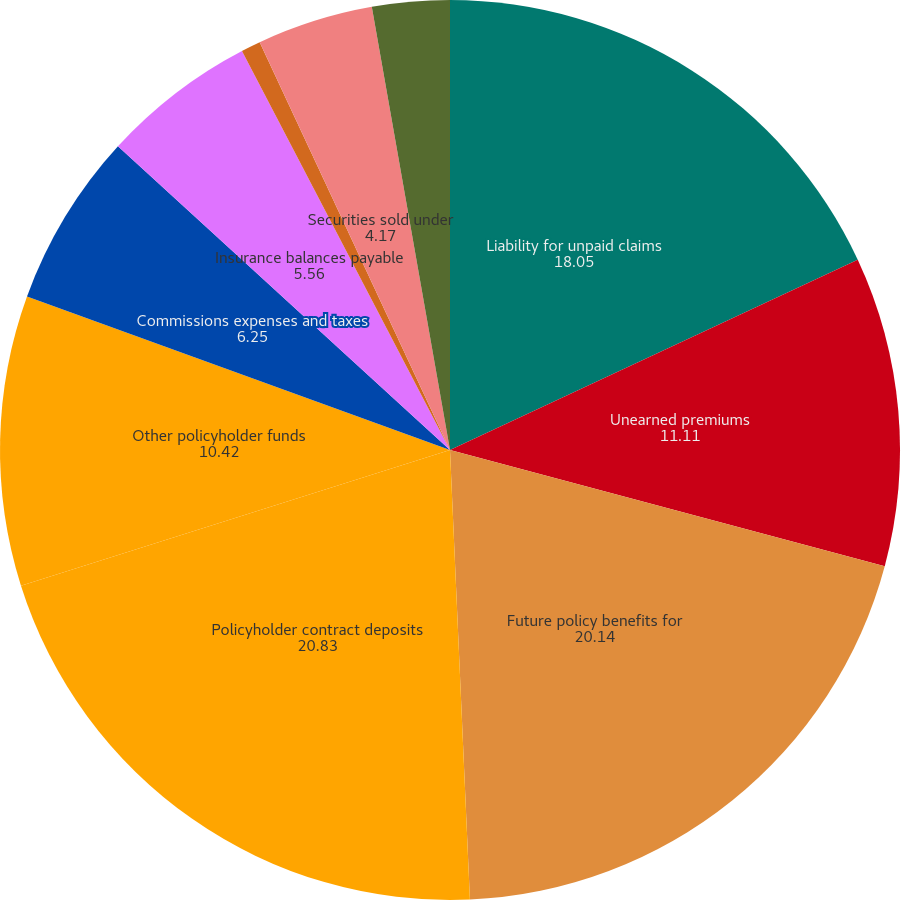<chart> <loc_0><loc_0><loc_500><loc_500><pie_chart><fcel>Liability for unpaid claims<fcel>Unearned premiums<fcel>Future policy benefits for<fcel>Policyholder contract deposits<fcel>Other policyholder funds<fcel>Commissions expenses and taxes<fcel>Insurance balances payable<fcel>Funds held by companies under<fcel>Securities sold under<fcel>Securities and spot<nl><fcel>18.05%<fcel>11.11%<fcel>20.14%<fcel>20.83%<fcel>10.42%<fcel>6.25%<fcel>5.56%<fcel>0.7%<fcel>4.17%<fcel>2.78%<nl></chart> 